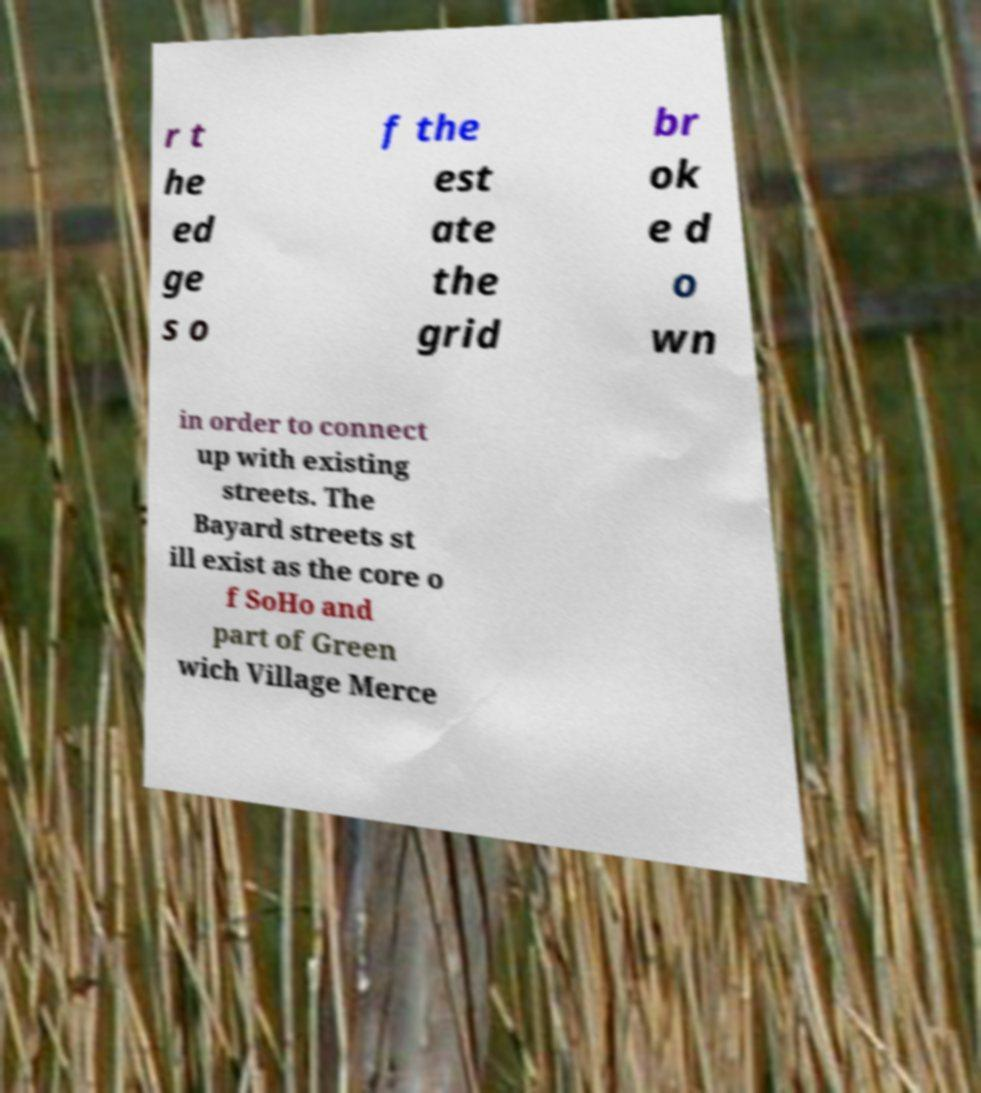For documentation purposes, I need the text within this image transcribed. Could you provide that? r t he ed ge s o f the est ate the grid br ok e d o wn in order to connect up with existing streets. The Bayard streets st ill exist as the core o f SoHo and part of Green wich Village Merce 